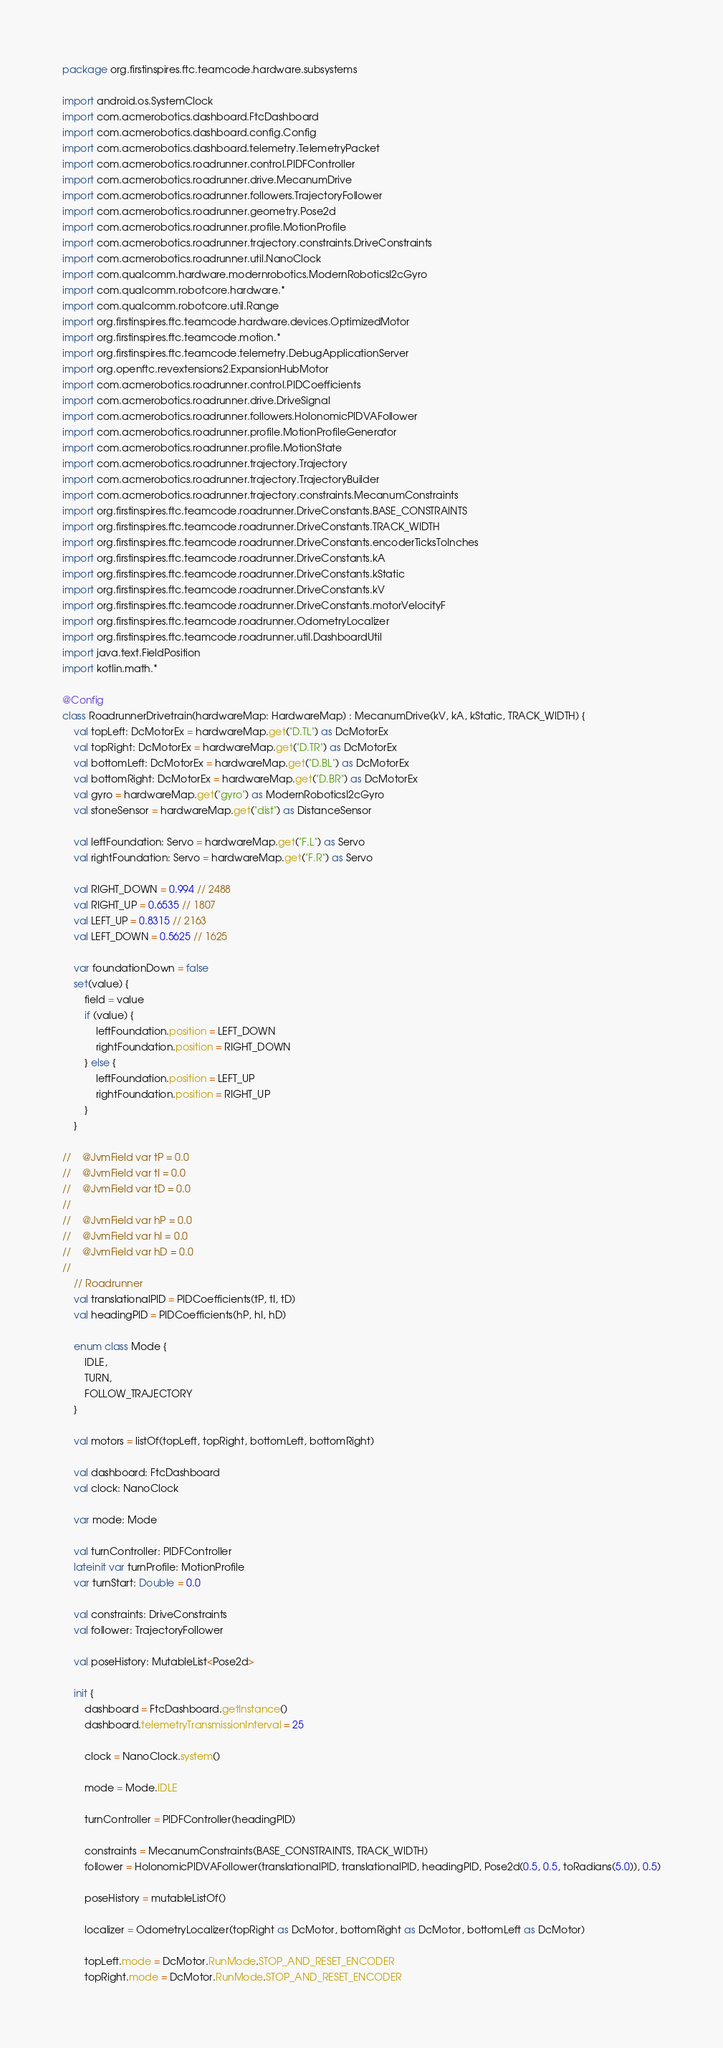Convert code to text. <code><loc_0><loc_0><loc_500><loc_500><_Kotlin_>package org.firstinspires.ftc.teamcode.hardware.subsystems

import android.os.SystemClock
import com.acmerobotics.dashboard.FtcDashboard
import com.acmerobotics.dashboard.config.Config
import com.acmerobotics.dashboard.telemetry.TelemetryPacket
import com.acmerobotics.roadrunner.control.PIDFController
import com.acmerobotics.roadrunner.drive.MecanumDrive
import com.acmerobotics.roadrunner.followers.TrajectoryFollower
import com.acmerobotics.roadrunner.geometry.Pose2d
import com.acmerobotics.roadrunner.profile.MotionProfile
import com.acmerobotics.roadrunner.trajectory.constraints.DriveConstraints
import com.acmerobotics.roadrunner.util.NanoClock
import com.qualcomm.hardware.modernrobotics.ModernRoboticsI2cGyro
import com.qualcomm.robotcore.hardware.*
import com.qualcomm.robotcore.util.Range
import org.firstinspires.ftc.teamcode.hardware.devices.OptimizedMotor
import org.firstinspires.ftc.teamcode.motion.*
import org.firstinspires.ftc.teamcode.telemetry.DebugApplicationServer
import org.openftc.revextensions2.ExpansionHubMotor
import com.acmerobotics.roadrunner.control.PIDCoefficients
import com.acmerobotics.roadrunner.drive.DriveSignal
import com.acmerobotics.roadrunner.followers.HolonomicPIDVAFollower
import com.acmerobotics.roadrunner.profile.MotionProfileGenerator
import com.acmerobotics.roadrunner.profile.MotionState
import com.acmerobotics.roadrunner.trajectory.Trajectory
import com.acmerobotics.roadrunner.trajectory.TrajectoryBuilder
import com.acmerobotics.roadrunner.trajectory.constraints.MecanumConstraints
import org.firstinspires.ftc.teamcode.roadrunner.DriveConstants.BASE_CONSTRAINTS
import org.firstinspires.ftc.teamcode.roadrunner.DriveConstants.TRACK_WIDTH
import org.firstinspires.ftc.teamcode.roadrunner.DriveConstants.encoderTicksToInches
import org.firstinspires.ftc.teamcode.roadrunner.DriveConstants.kA
import org.firstinspires.ftc.teamcode.roadrunner.DriveConstants.kStatic
import org.firstinspires.ftc.teamcode.roadrunner.DriveConstants.kV
import org.firstinspires.ftc.teamcode.roadrunner.DriveConstants.motorVelocityF
import org.firstinspires.ftc.teamcode.roadrunner.OdometryLocalizer
import org.firstinspires.ftc.teamcode.roadrunner.util.DashboardUtil
import java.text.FieldPosition
import kotlin.math.*

@Config
class RoadrunnerDrivetrain(hardwareMap: HardwareMap) : MecanumDrive(kV, kA, kStatic, TRACK_WIDTH) {
    val topLeft: DcMotorEx = hardwareMap.get("D.TL") as DcMotorEx
    val topRight: DcMotorEx = hardwareMap.get("D.TR") as DcMotorEx
    val bottomLeft: DcMotorEx = hardwareMap.get("D.BL") as DcMotorEx
    val bottomRight: DcMotorEx = hardwareMap.get("D.BR") as DcMotorEx
    val gyro = hardwareMap.get("gyro") as ModernRoboticsI2cGyro
    val stoneSensor = hardwareMap.get("dist") as DistanceSensor

    val leftFoundation: Servo = hardwareMap.get("F.L") as Servo
    val rightFoundation: Servo = hardwareMap.get("F.R") as Servo

    val RIGHT_DOWN = 0.994 // 2488
    val RIGHT_UP = 0.6535 // 1807
    val LEFT_UP = 0.8315 // 2163
    val LEFT_DOWN = 0.5625 // 1625

    var foundationDown = false
    set(value) {
        field = value
        if (value) {
            leftFoundation.position = LEFT_DOWN
            rightFoundation.position = RIGHT_DOWN
        } else {
            leftFoundation.position = LEFT_UP
            rightFoundation.position = RIGHT_UP
        }
    }

//    @JvmField var tP = 0.0
//    @JvmField var tI = 0.0
//    @JvmField var tD = 0.0
//
//    @JvmField var hP = 0.0
//    @JvmField var hI = 0.0
//    @JvmField var hD = 0.0
//
    // Roadrunner
    val translationalPID = PIDCoefficients(tP, tI, tD)
    val headingPID = PIDCoefficients(hP, hI, hD)

    enum class Mode {
        IDLE,
        TURN,
        FOLLOW_TRAJECTORY
    }

    val motors = listOf(topLeft, topRight, bottomLeft, bottomRight)

    val dashboard: FtcDashboard
    val clock: NanoClock

    var mode: Mode

    val turnController: PIDFController
    lateinit var turnProfile: MotionProfile
    var turnStart: Double = 0.0

    val constraints: DriveConstraints
    val follower: TrajectoryFollower

    val poseHistory: MutableList<Pose2d>

    init {
        dashboard = FtcDashboard.getInstance()
        dashboard.telemetryTransmissionInterval = 25

        clock = NanoClock.system()

        mode = Mode.IDLE

        turnController = PIDFController(headingPID)

        constraints = MecanumConstraints(BASE_CONSTRAINTS, TRACK_WIDTH)
        follower = HolonomicPIDVAFollower(translationalPID, translationalPID, headingPID, Pose2d(0.5, 0.5, toRadians(5.0)), 0.5)

        poseHistory = mutableListOf()

        localizer = OdometryLocalizer(topRight as DcMotor, bottomRight as DcMotor, bottomLeft as DcMotor)

        topLeft.mode = DcMotor.RunMode.STOP_AND_RESET_ENCODER
        topRight.mode = DcMotor.RunMode.STOP_AND_RESET_ENCODER</code> 